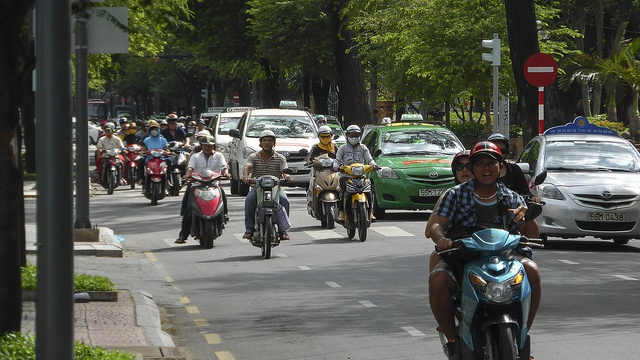Describe the objects in this image and their specific colors. I can see car in black, lightgray, darkgray, and gray tones, people in black, maroon, gray, and blue tones, motorcycle in black, gray, and blue tones, car in black, gray, darkgreen, and darkgray tones, and car in black, white, darkgray, and gray tones in this image. 